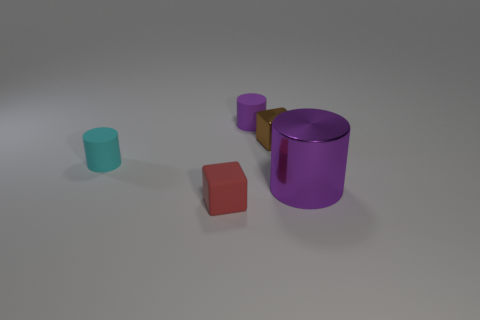How many large purple metallic cylinders are in front of the small cylinder in front of the small cube behind the tiny red matte cube?
Keep it short and to the point. 1. The cylinder behind the cube that is behind the red thing is what color?
Provide a short and direct response. Purple. Are there any cyan matte cylinders that have the same size as the brown metal cube?
Provide a short and direct response. Yes. There is a object in front of the purple object in front of the object that is left of the red rubber cube; what is it made of?
Ensure brevity in your answer.  Rubber. What number of small purple objects are in front of the small cylinder in front of the tiny purple matte object?
Your answer should be very brief. 0. There is a shiny thing that is in front of the cyan object; is it the same size as the tiny purple cylinder?
Your answer should be very brief. No. How many small brown metallic objects have the same shape as the cyan thing?
Give a very brief answer. 0. What is the shape of the brown thing?
Keep it short and to the point. Cube. Is the number of small cylinders that are right of the tiny brown block the same as the number of small purple cylinders?
Offer a terse response. No. Is the tiny cylinder in front of the brown object made of the same material as the large cylinder?
Provide a succinct answer. No. 